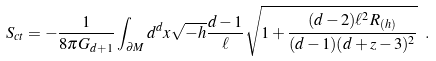Convert formula to latex. <formula><loc_0><loc_0><loc_500><loc_500>S _ { c t } = - \frac { 1 } { 8 \pi G _ { d + 1 } } \int _ { \partial M } d ^ { d } x \sqrt { - h } \frac { d - 1 } { \ell } \sqrt { 1 + \frac { ( d - 2 ) \ell ^ { 2 } R _ { ( h ) } } { ( d - 1 ) ( d + z - 3 ) ^ { 2 } } } \ .</formula> 